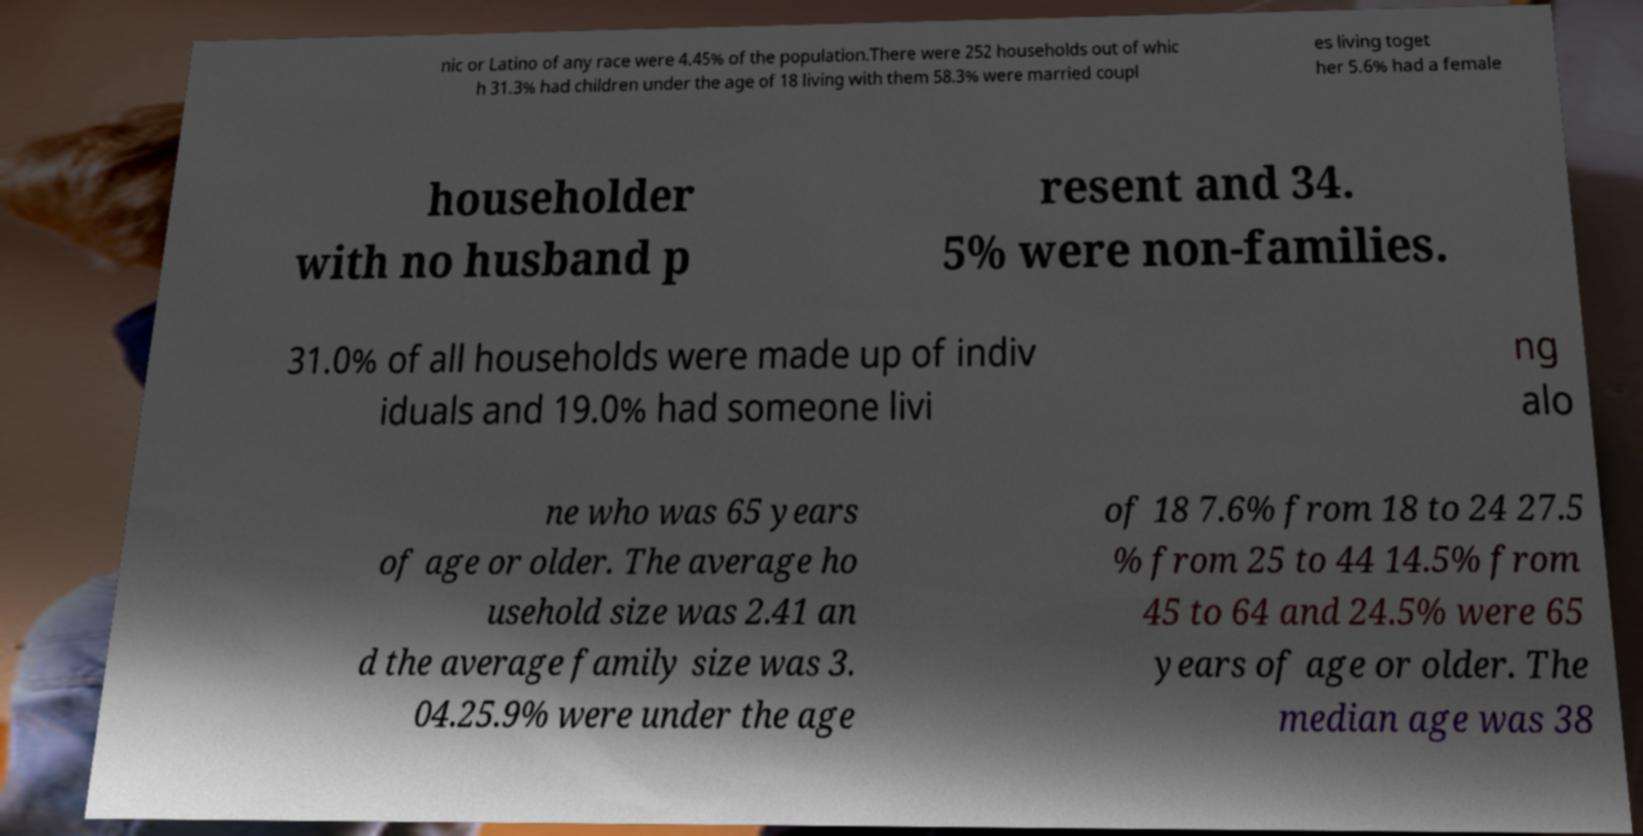Could you extract and type out the text from this image? nic or Latino of any race were 4.45% of the population.There were 252 households out of whic h 31.3% had children under the age of 18 living with them 58.3% were married coupl es living toget her 5.6% had a female householder with no husband p resent and 34. 5% were non-families. 31.0% of all households were made up of indiv iduals and 19.0% had someone livi ng alo ne who was 65 years of age or older. The average ho usehold size was 2.41 an d the average family size was 3. 04.25.9% were under the age of 18 7.6% from 18 to 24 27.5 % from 25 to 44 14.5% from 45 to 64 and 24.5% were 65 years of age or older. The median age was 38 